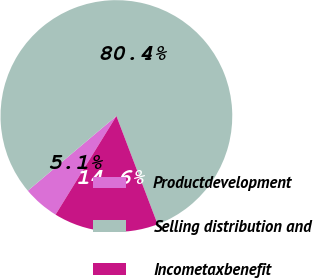<chart> <loc_0><loc_0><loc_500><loc_500><pie_chart><fcel>Productdevelopment<fcel>Selling distribution and<fcel>Incometaxbenefit<nl><fcel>5.05%<fcel>80.36%<fcel>14.59%<nl></chart> 